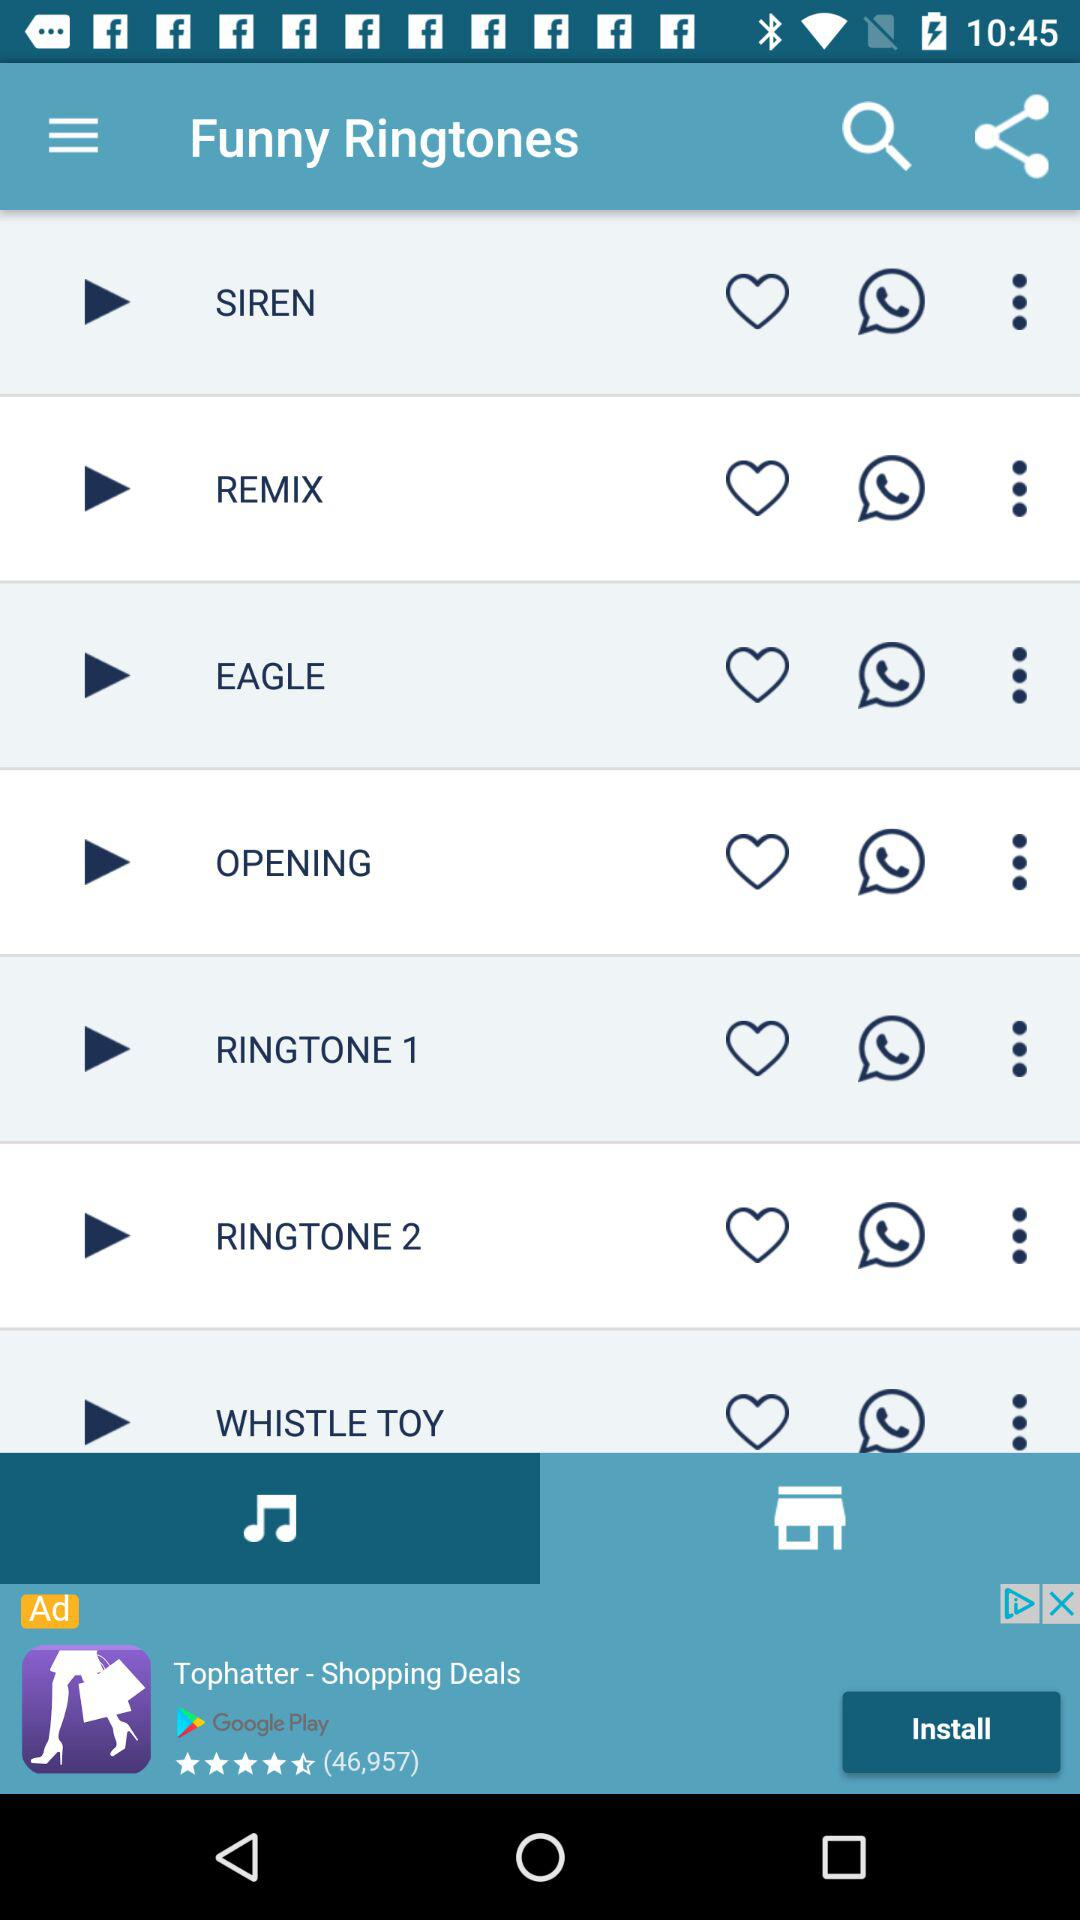What are the names of the ringtones in "Funny Ringtones"? The names of the ringtones in "Funny Ringtones" are "SIREN", "REMIX", "EAGLE", "OPENING", "RINGTONE 1", "RINGTONE 2" and "WHISTLE TOY". 